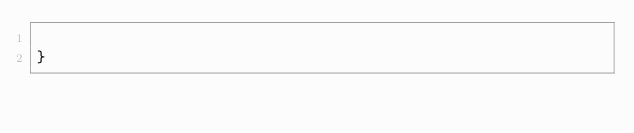<code> <loc_0><loc_0><loc_500><loc_500><_Java_>
}
</code> 